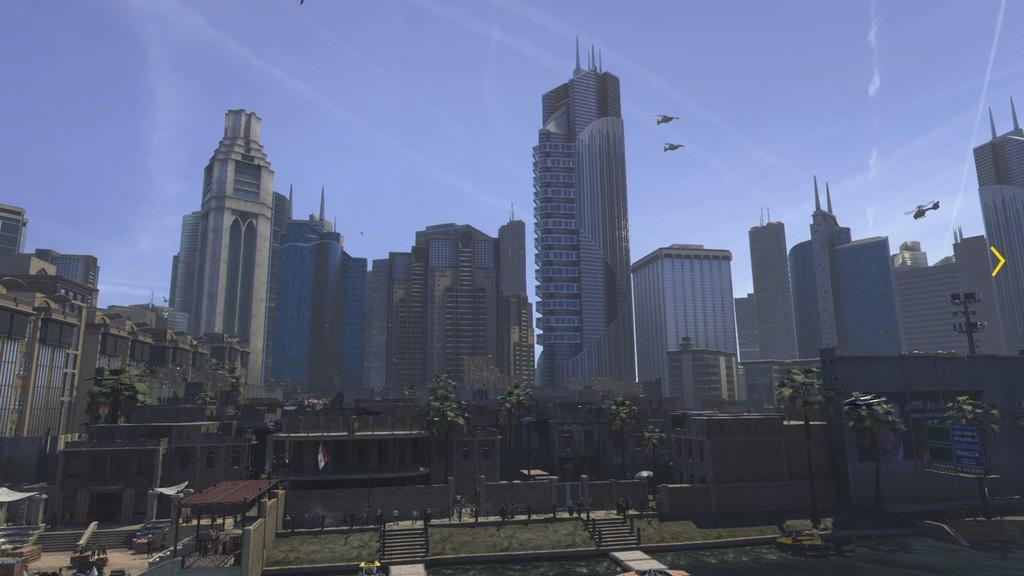What type of structures can be seen in the image? There are buildings in the image. What colors are the buildings? The buildings are in white and cream colors. What other natural elements are present in the image? There are trees in the image. What color are the trees? The trees are in green color. What is visible in the background of the image? The background of the image is the sky. What color is the sky? The sky is in blue color. What type of lettuce can be seen growing in the image? There is no lettuce present in the image; it features buildings, trees, and a blue sky. What act are the buildings performing in the image? Buildings are inanimate structures and cannot perform acts; they are simply standing in the image. 